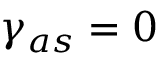Convert formula to latex. <formula><loc_0><loc_0><loc_500><loc_500>\gamma _ { a s } = 0</formula> 